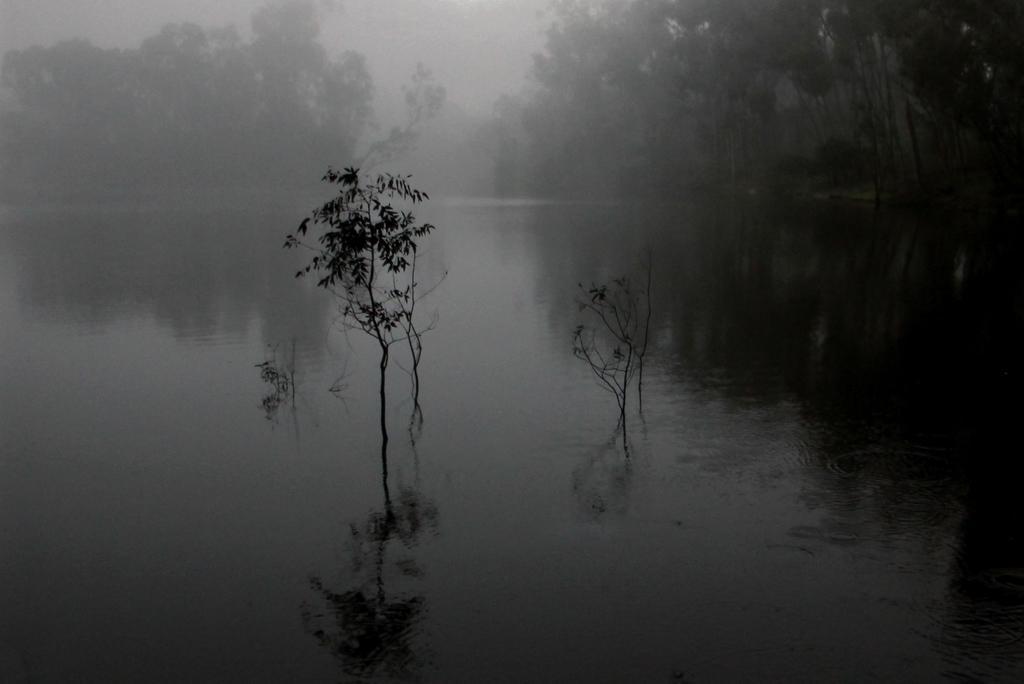What is present in the image that is not solid? There is water in the image. What type of vegetation can be seen in the image? There are trees in the image. What atmospheric condition is visible in the image? There is fog visible in the image. How many buns are present in the image? There are no buns present in the image. What type of slave can be seen in the image? There is no slave present in the image. 